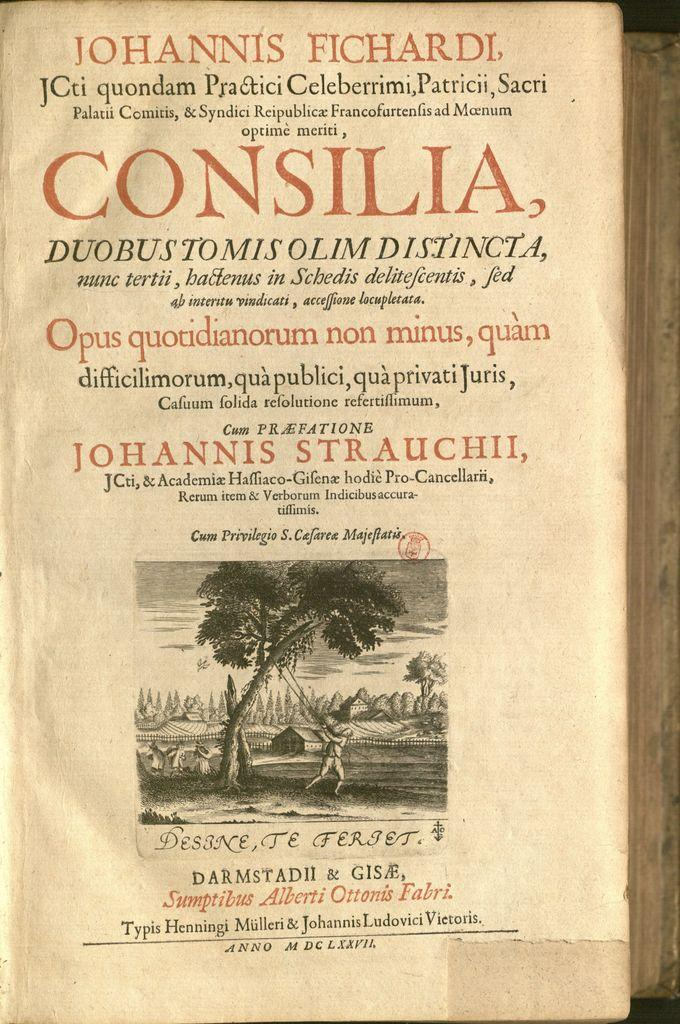Provide a one-sentence caption for the provided image. old book about johannis strauchii, in another language. 